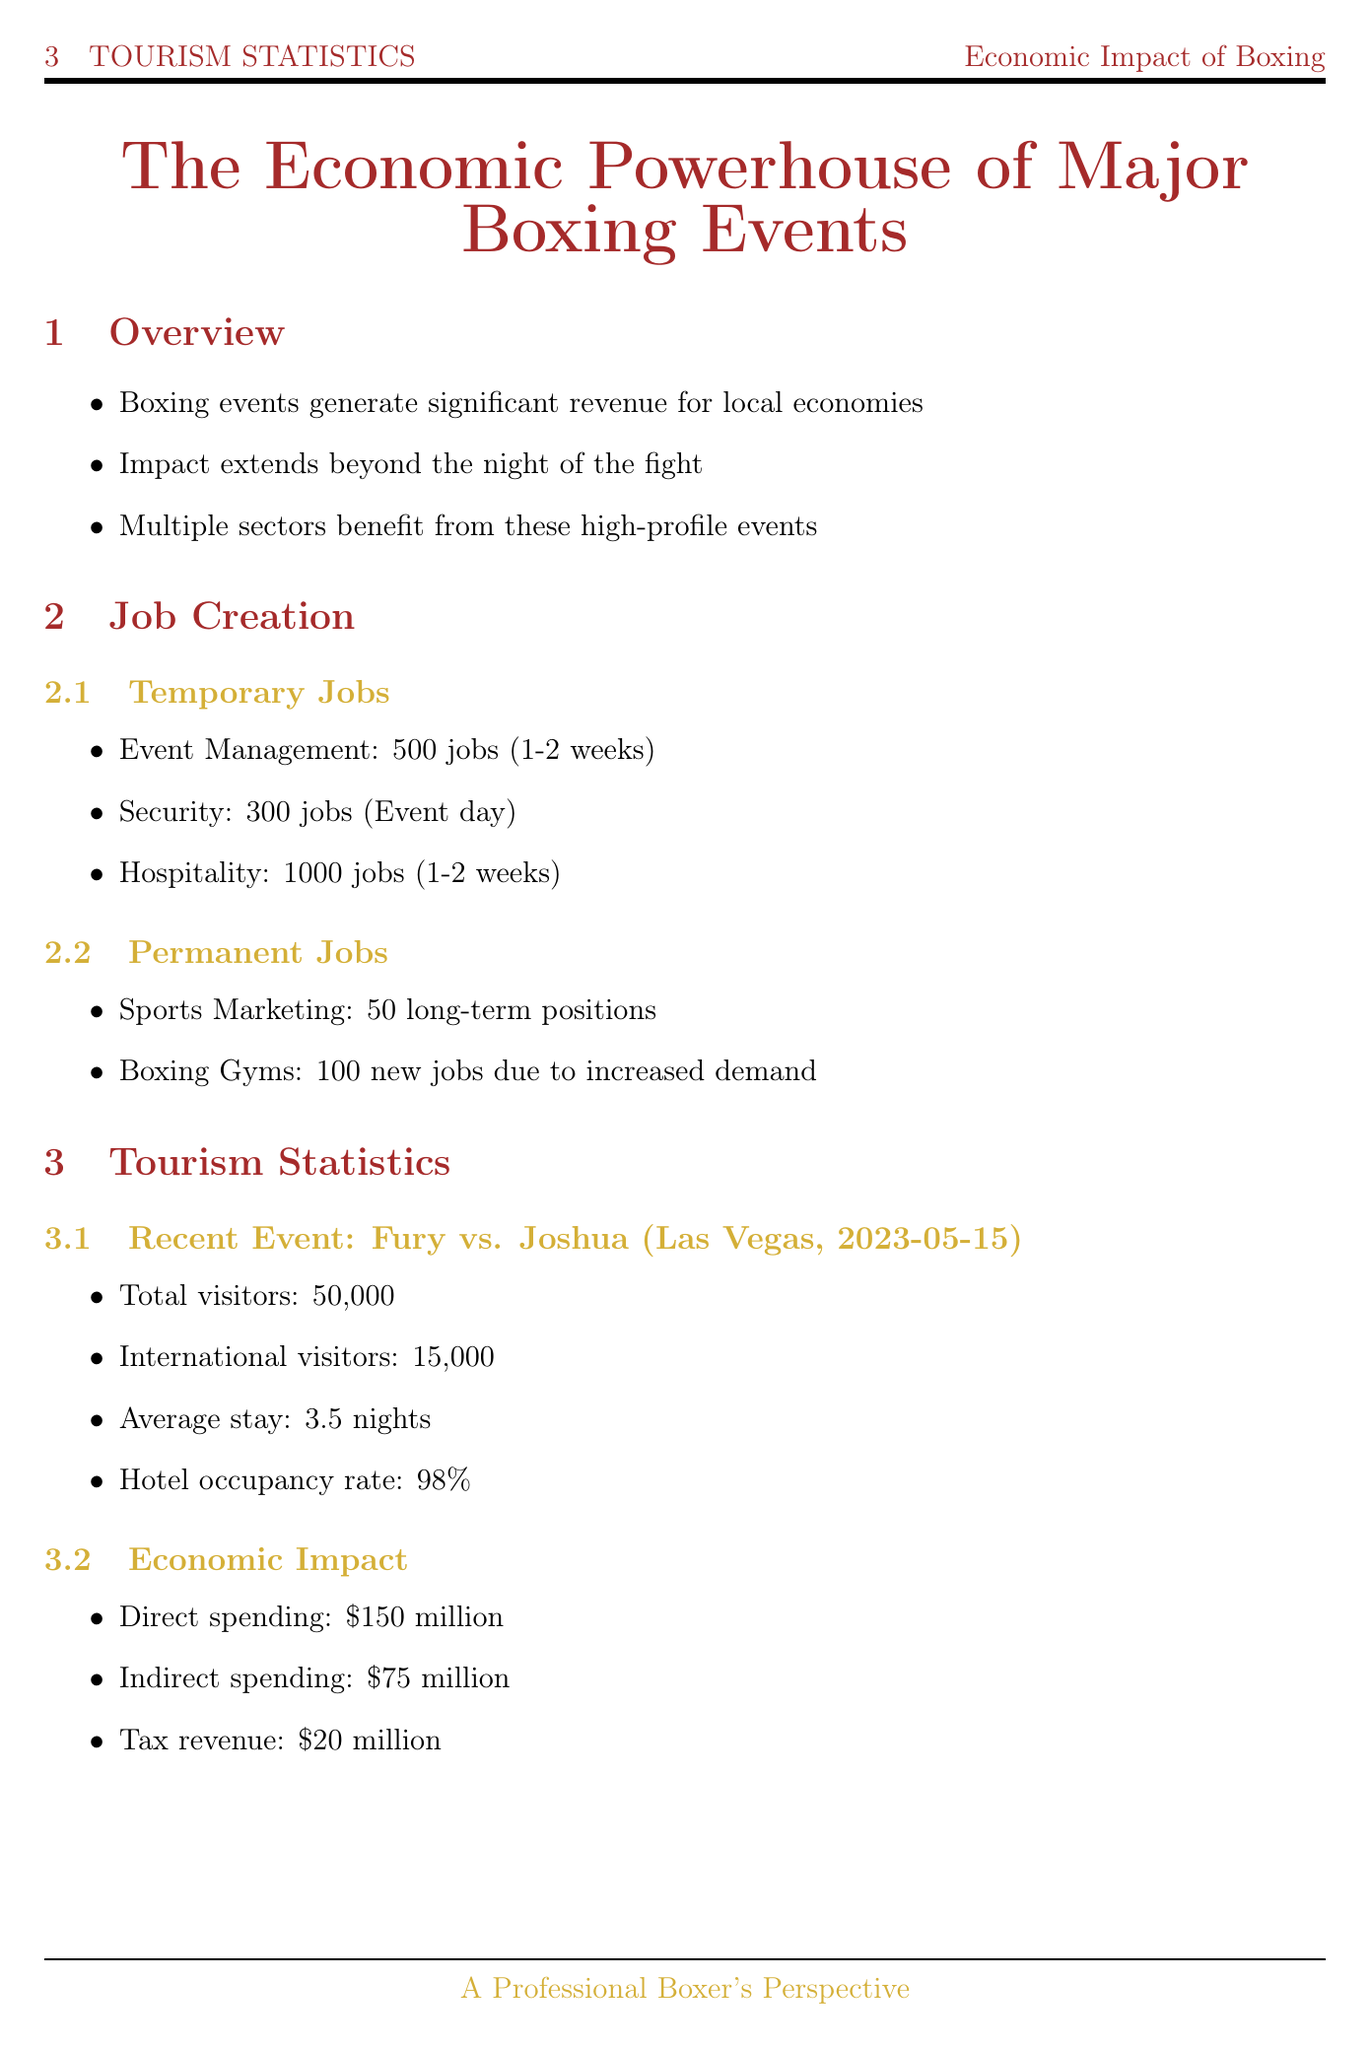What is the title of the report? The title is stated at the beginning of the document, summarizing its focus on economic impacts.
Answer: The Economic Powerhouse of Major Boxing Events How many temporary jobs are estimated to be created in the hospitality sector? The document specifies the number of estimated jobs for each sector. In hospitality, it mentions 1000 jobs.
Answer: 1000 What was the hotel occupancy rate during the Canelo vs. GGG III event? The report provides specific statistics regarding hotel occupancy for this particular event.
Answer: 98% What is the direct spending reported for the Fury vs. Joshua event? This figure is given in the tourism statistics section for the recent event discussed.
Answer: $150 million What is a notable effect of the Joshua vs. Usyk II event? The document includes a list of notable effects for this event, highlighting its impact on tourism and local businesses.
Answer: Increased international flight bookings by 40% What key message does the boxer perspective section convey? This section emphasizes the broader impact boxing events have, as seen through the eyes of a professional boxer.
Answer: Boxing events are catalysts for economic growth and job creation What was the economic impact of the Canelo vs. GGG III event? The document summarizes the economic impact in monetary terms for this significant event.
Answer: $125 million Which sector created the most temporary jobs for major boxing events? The document details multiple sectors creating temporary jobs, with hospitality having the highest figure.
Answer: Hospitality 